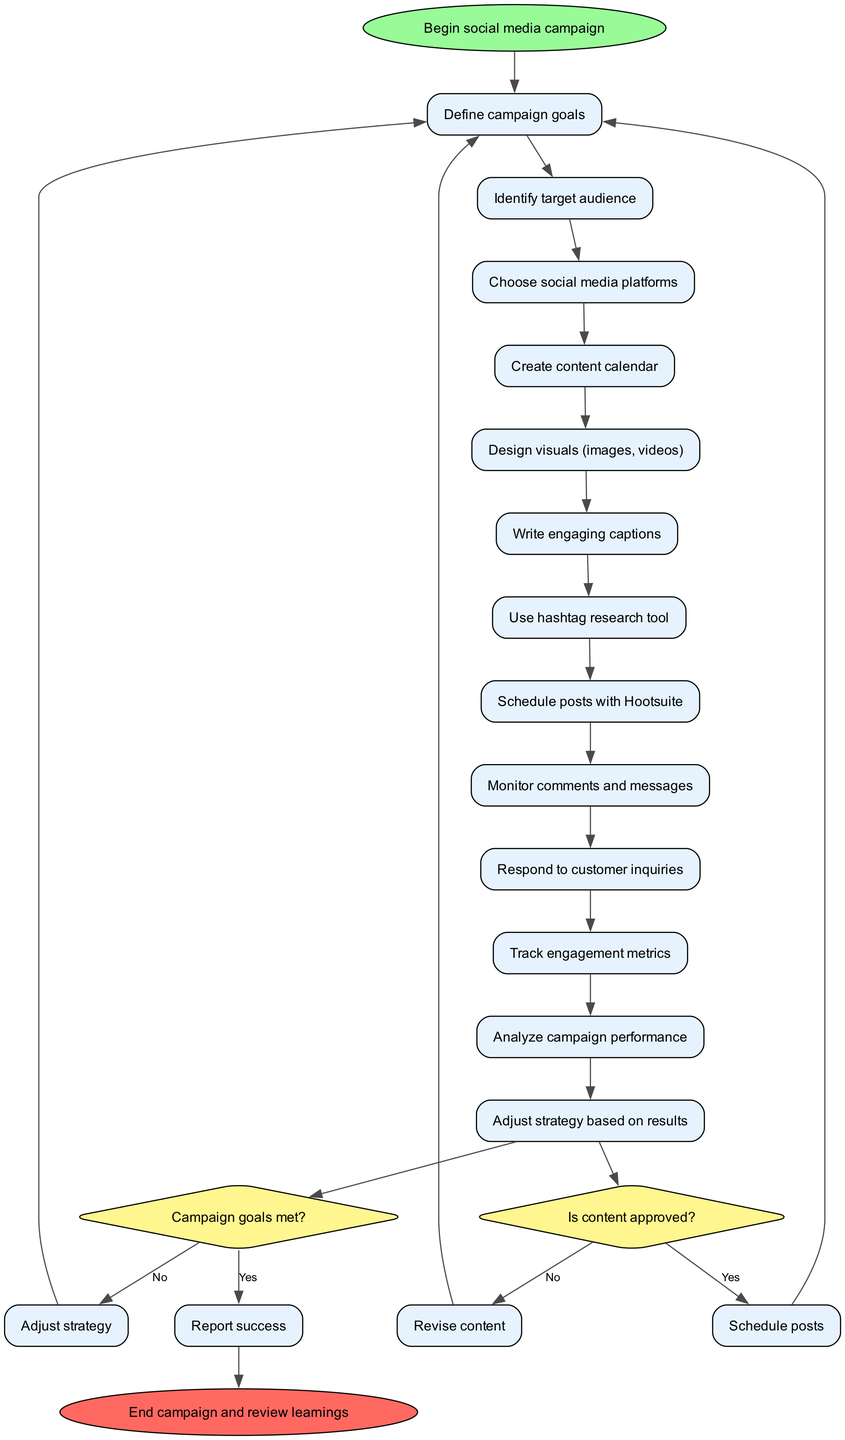What is the first activity in the workflow? The diagram begins with the "Begin social media campaign" node, then proceeds to the first activity which is "Define campaign goals." Therefore, the first activity mentioned is "Define campaign goals."
Answer: Define campaign goals How many total activities are listed in the diagram? The diagram includes a total of 13 activities listed under the activities section. This can be counted directly from the activities array in the data.
Answer: 13 What decision follows the last activity? After the last activity, which is "Adjust strategy based on results," the diagram moves to the decision point asking, "Is content approved?" This indicates that the next logical step is the decision node directly following the last activity.
Answer: Is content approved? If the content is not approved, what is the next step? If the answer to the decision "Is content approved?" is "No," the next step specified in the diagram is "Revise content." This comes directly from the flow outlined between the decision node and its "No" branch.
Answer: Revise content If campaign goals are met, what is the next activity? If the decision "Campaign goals met?" answers "Yes," the flow indicates to proceed to "Report success," which is the sequence of actions that follows a positive decision at this node.
Answer: Report success What activity is performed after scheduling posts? After the decision from "Is content approved?" leads to "Schedule posts," the next activity that follows is "Monitor comments and messages." This connection can be traced from the flow outlines around the scheduling process.
Answer: Monitor comments and messages What is the last node in the workflow? The final node in the diagram is labeled "End campaign and review learnings," signaling the completion of the entire workflow. This is the conclusion stated at the end of the diagram.
Answer: End campaign and review learnings How does the workflow respond if the campaign goals are not met? If the results show that the "Campaign goals met?" decision is "No," according to the diagram, the flow leads to the action to "Adjust strategy." This illustrates the response protocol in the case of unmet goals.
Answer: Adjust strategy 